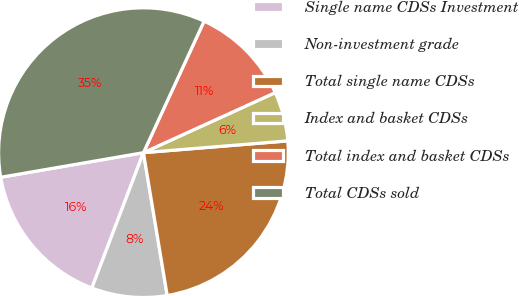Convert chart to OTSL. <chart><loc_0><loc_0><loc_500><loc_500><pie_chart><fcel>Single name CDSs Investment<fcel>Non-investment grade<fcel>Total single name CDSs<fcel>Index and basket CDSs<fcel>Total index and basket CDSs<fcel>Total CDSs sold<nl><fcel>16.49%<fcel>8.42%<fcel>23.67%<fcel>5.51%<fcel>11.32%<fcel>34.6%<nl></chart> 